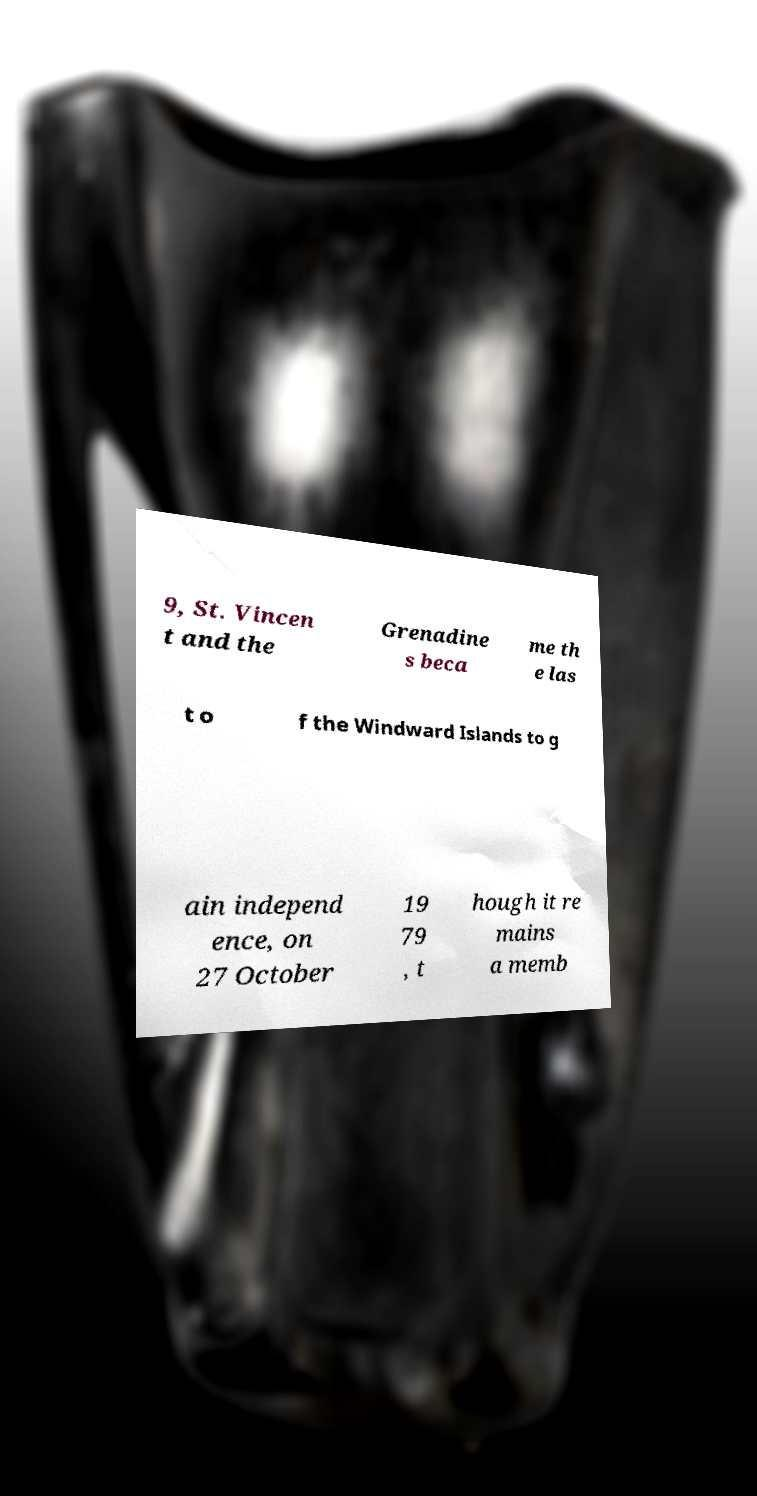Please identify and transcribe the text found in this image. 9, St. Vincen t and the Grenadine s beca me th e las t o f the Windward Islands to g ain independ ence, on 27 October 19 79 , t hough it re mains a memb 